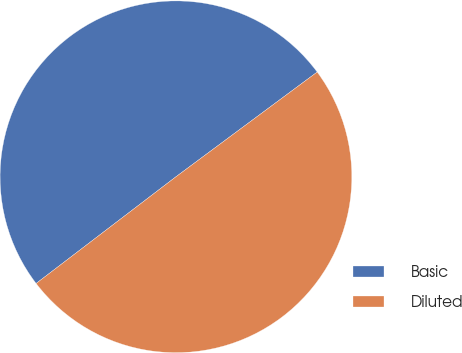Convert chart. <chart><loc_0><loc_0><loc_500><loc_500><pie_chart><fcel>Basic<fcel>Diluted<nl><fcel>50.22%<fcel>49.78%<nl></chart> 